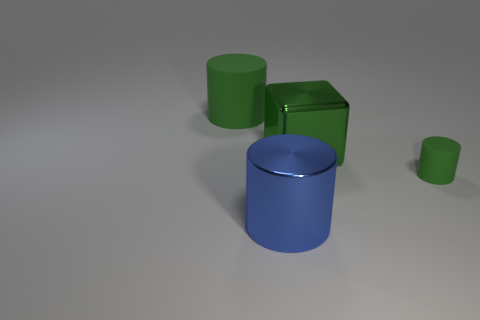Add 4 large cyan rubber cylinders. How many objects exist? 8 Subtract all cubes. How many objects are left? 3 Subtract all big matte cylinders. Subtract all blocks. How many objects are left? 2 Add 2 blue cylinders. How many blue cylinders are left? 3 Add 1 large cubes. How many large cubes exist? 2 Subtract 0 purple cylinders. How many objects are left? 4 